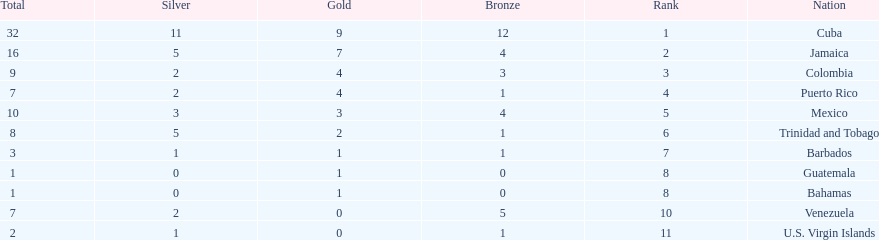Nations that had 10 or more medals each Cuba, Jamaica, Mexico. 